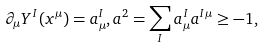<formula> <loc_0><loc_0><loc_500><loc_500>\partial _ { \mu } Y ^ { I } ( x ^ { \mu } ) = a _ { \mu } ^ { I } , a ^ { 2 } = \sum _ { I } a _ { \mu } ^ { I } a ^ { I \mu } \geq - 1 ,</formula> 